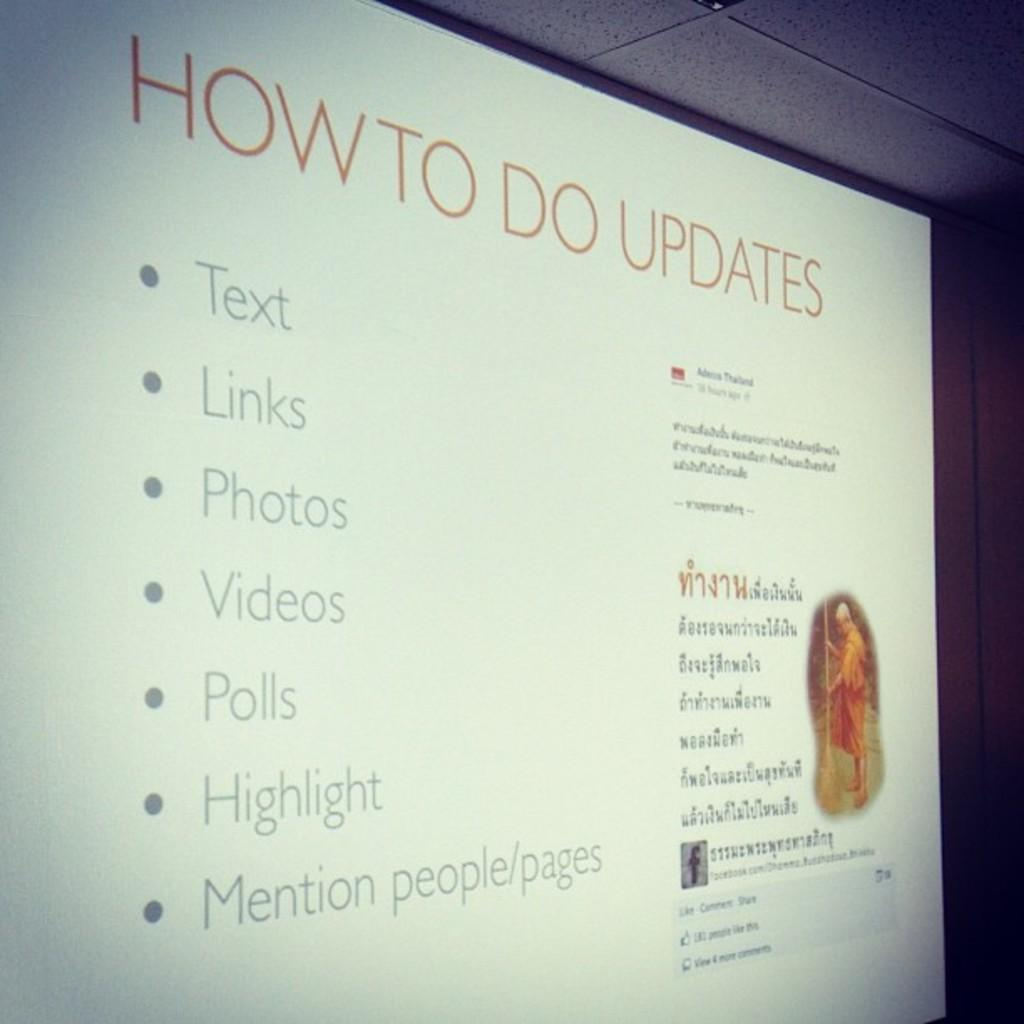<image>
Provide a brief description of the given image. A computer screen showing text, how to do updates with lists of things to do 